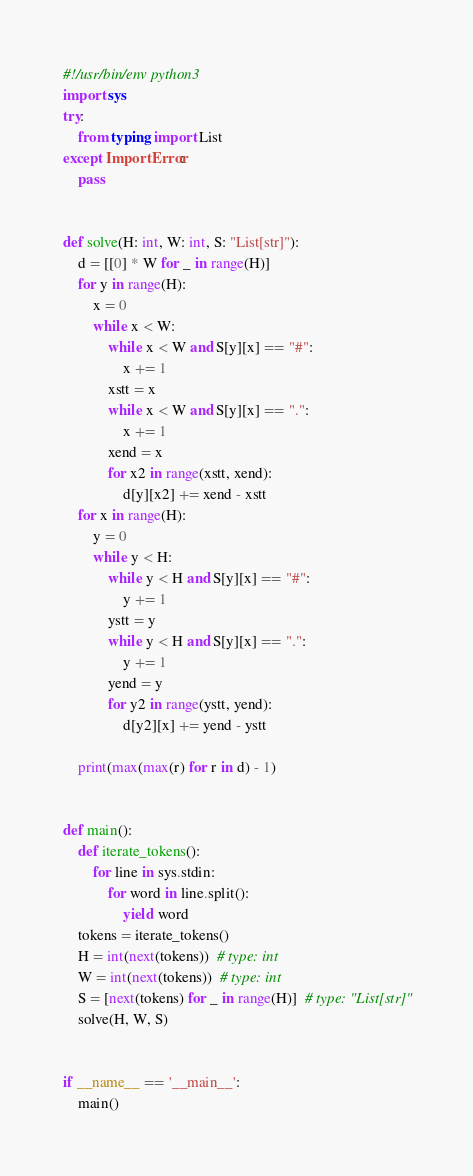<code> <loc_0><loc_0><loc_500><loc_500><_Python_>#!/usr/bin/env python3
import sys
try:
    from typing import List
except ImportError:
    pass


def solve(H: int, W: int, S: "List[str]"):
    d = [[0] * W for _ in range(H)]
    for y in range(H):
        x = 0
        while x < W:
            while x < W and S[y][x] == "#":
                x += 1
            xstt = x
            while x < W and S[y][x] == ".":
                x += 1
            xend = x
            for x2 in range(xstt, xend):
                d[y][x2] += xend - xstt
    for x in range(H):
        y = 0
        while y < H:
            while y < H and S[y][x] == "#":
                y += 1
            ystt = y
            while y < H and S[y][x] == ".":
                y += 1
            yend = y
            for y2 in range(ystt, yend):
                d[y2][x] += yend - ystt

    print(max(max(r) for r in d) - 1)


def main():
    def iterate_tokens():
        for line in sys.stdin:
            for word in line.split():
                yield word
    tokens = iterate_tokens()
    H = int(next(tokens))  # type: int
    W = int(next(tokens))  # type: int
    S = [next(tokens) for _ in range(H)]  # type: "List[str]"
    solve(H, W, S)


if __name__ == '__main__':
    main()
</code> 